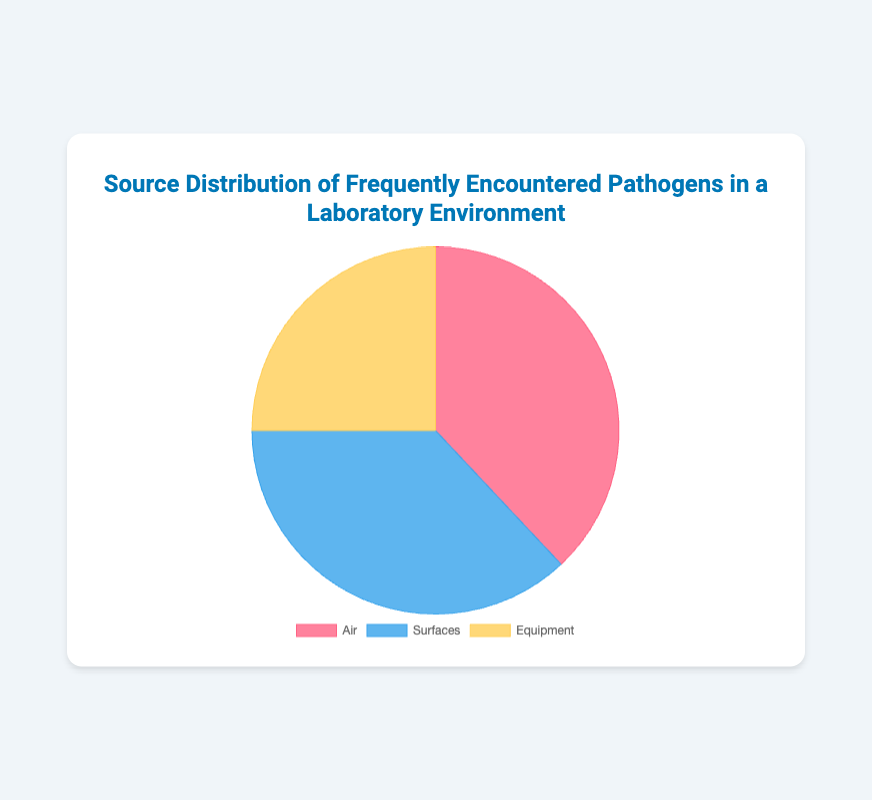Which source has the highest percentage of frequently encountered pathogens? The pie chart shows the distribution of pathogens among Air, Surfaces, and Equipment. Air has the largest segment, indicating the highest percentage.
Answer: Air How much higher is the percentage of pathogens from Air compared to Equipment? The pie chart shows that the percentage for Air is 38% and for Equipment is 25%. Subtracting these values gives us the difference: 38% - 25% = 13%.
Answer: 13% Which source has the smallest percentage of frequently encountered pathogens? The pie chart has segments for Air, Surfaces, and Equipment, with Equipment having the smallest segment.
Answer: Equipment What is the combined percentage of pathogens from Air and Surfaces? The pie chart lists Air at 38% and Surfaces at 37%. Adding these together gives us 38% + 37% = 75%.
Answer: 75% How does the percentage of pathogens from Surfaces compare to the percentage from Air? The chart shows Surfaces at 37% and Air at 38%. Comparing these percentages, Surfaces has 1% less than Air.
Answer: Surfaces has 1% less What color represents Surfaces in the pie chart? Observing the pie chart, Surfaces is represented by the blue segment.
Answer: Blue If you were to isolate the segment for Equipment, what percentage of the chart would it cover? The pie chart indicates that Equipment accounts for 25% of the pathogens.
Answer: 25% Is the percentage of pathogens from Air greater than or less than the percentage of pathogens from Surfaces and Equipment combined? Air is 38%, while Surfaces and Equipment combined are 37% + 25% = 62%. Air (38%) is less than the combined percentage of Surfaces and Equipment (62%).
Answer: Less What is the average percentage of pathogens from the three sources? The percentages are 38% for Air, 37% for Surfaces, and 25% for Equipment. The average is calculated by summing these values and dividing by three: (38% + 37% + 25%) / 3 = 33.33%.
Answer: 33.33% 